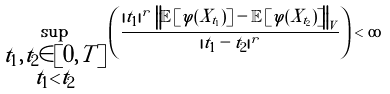Convert formula to latex. <formula><loc_0><loc_0><loc_500><loc_500>\sup _ { \substack { t _ { 1 } , t _ { 2 } \in [ 0 , T ] \\ t _ { 1 } < t _ { 2 } } } \left ( \frac { | t _ { 1 } | ^ { r } \, \left \| \mathbb { E } \left [ \varphi ( X _ { t _ { 1 } } ) \right ] - \mathbb { E } \left [ \varphi ( X _ { t _ { 2 } } ) \right ] \right \| _ { V } } { | t _ { 1 } - t _ { 2 } | ^ { r } } \right ) < \infty</formula> 